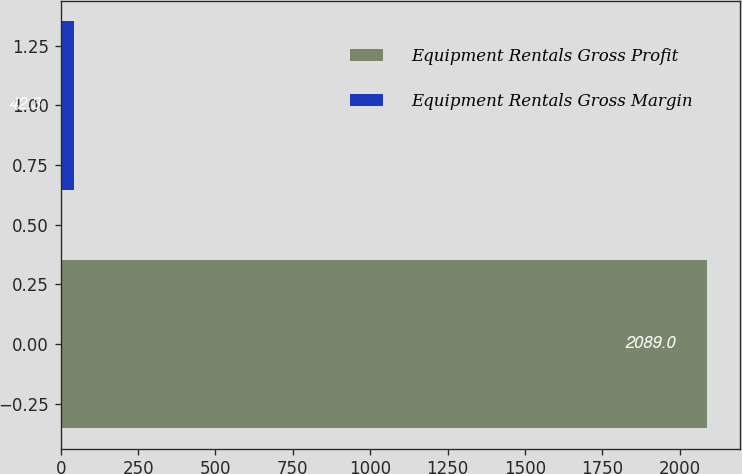<chart> <loc_0><loc_0><loc_500><loc_500><bar_chart><fcel>Equipment Rentals Gross Profit<fcel>Equipment Rentals Gross Margin<nl><fcel>2089<fcel>42.3<nl></chart> 